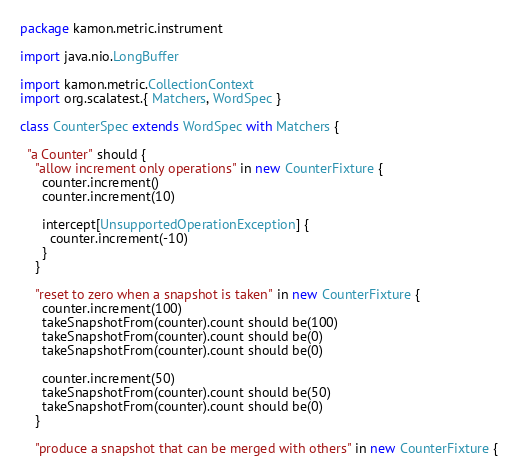<code> <loc_0><loc_0><loc_500><loc_500><_Scala_>package kamon.metric.instrument

import java.nio.LongBuffer

import kamon.metric.CollectionContext
import org.scalatest.{ Matchers, WordSpec }

class CounterSpec extends WordSpec with Matchers {

  "a Counter" should {
    "allow increment only operations" in new CounterFixture {
      counter.increment()
      counter.increment(10)

      intercept[UnsupportedOperationException] {
        counter.increment(-10)
      }
    }

    "reset to zero when a snapshot is taken" in new CounterFixture {
      counter.increment(100)
      takeSnapshotFrom(counter).count should be(100)
      takeSnapshotFrom(counter).count should be(0)
      takeSnapshotFrom(counter).count should be(0)

      counter.increment(50)
      takeSnapshotFrom(counter).count should be(50)
      takeSnapshotFrom(counter).count should be(0)
    }

    "produce a snapshot that can be merged with others" in new CounterFixture {</code> 